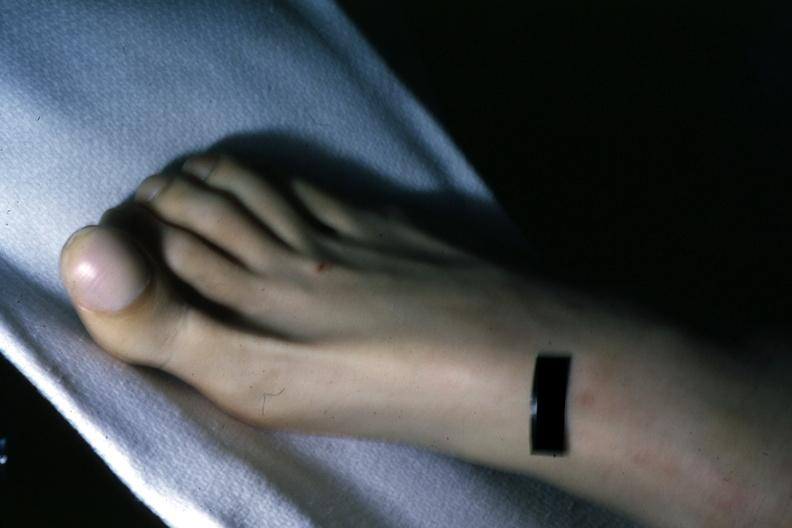s pulmonary osteoarthropathy present?
Answer the question using a single word or phrase. Yes 